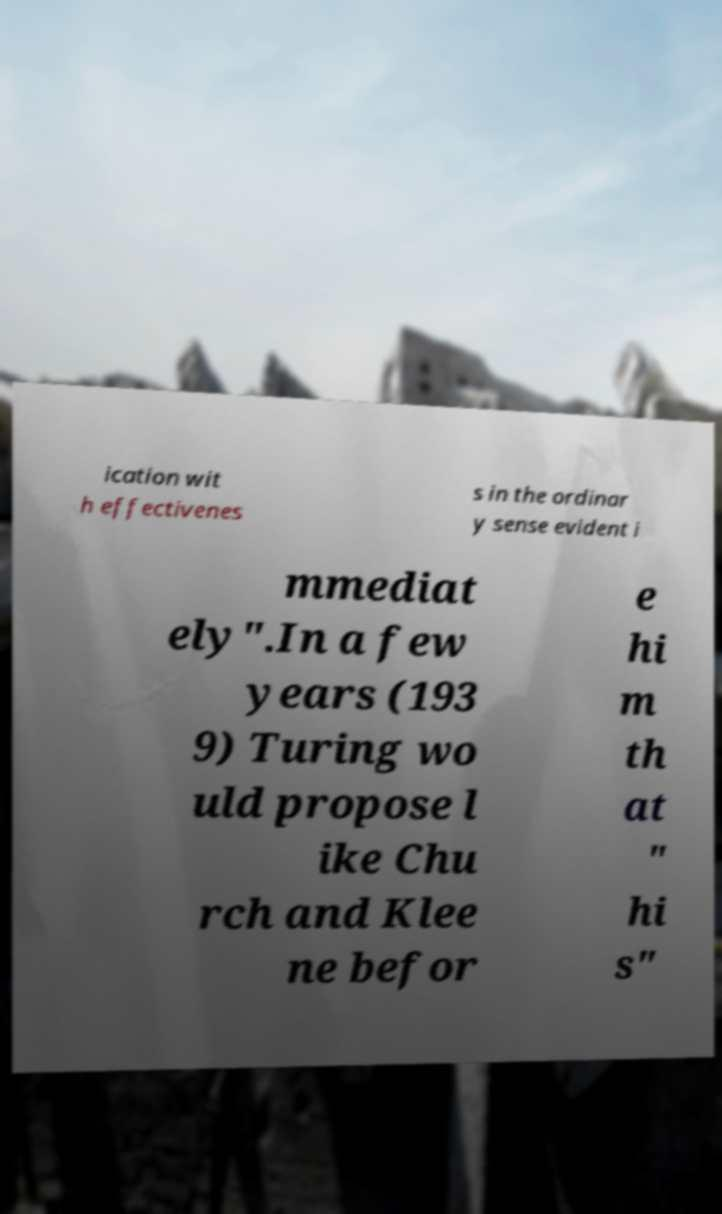Can you read and provide the text displayed in the image?This photo seems to have some interesting text. Can you extract and type it out for me? ication wit h effectivenes s in the ordinar y sense evident i mmediat ely".In a few years (193 9) Turing wo uld propose l ike Chu rch and Klee ne befor e hi m th at " hi s" 